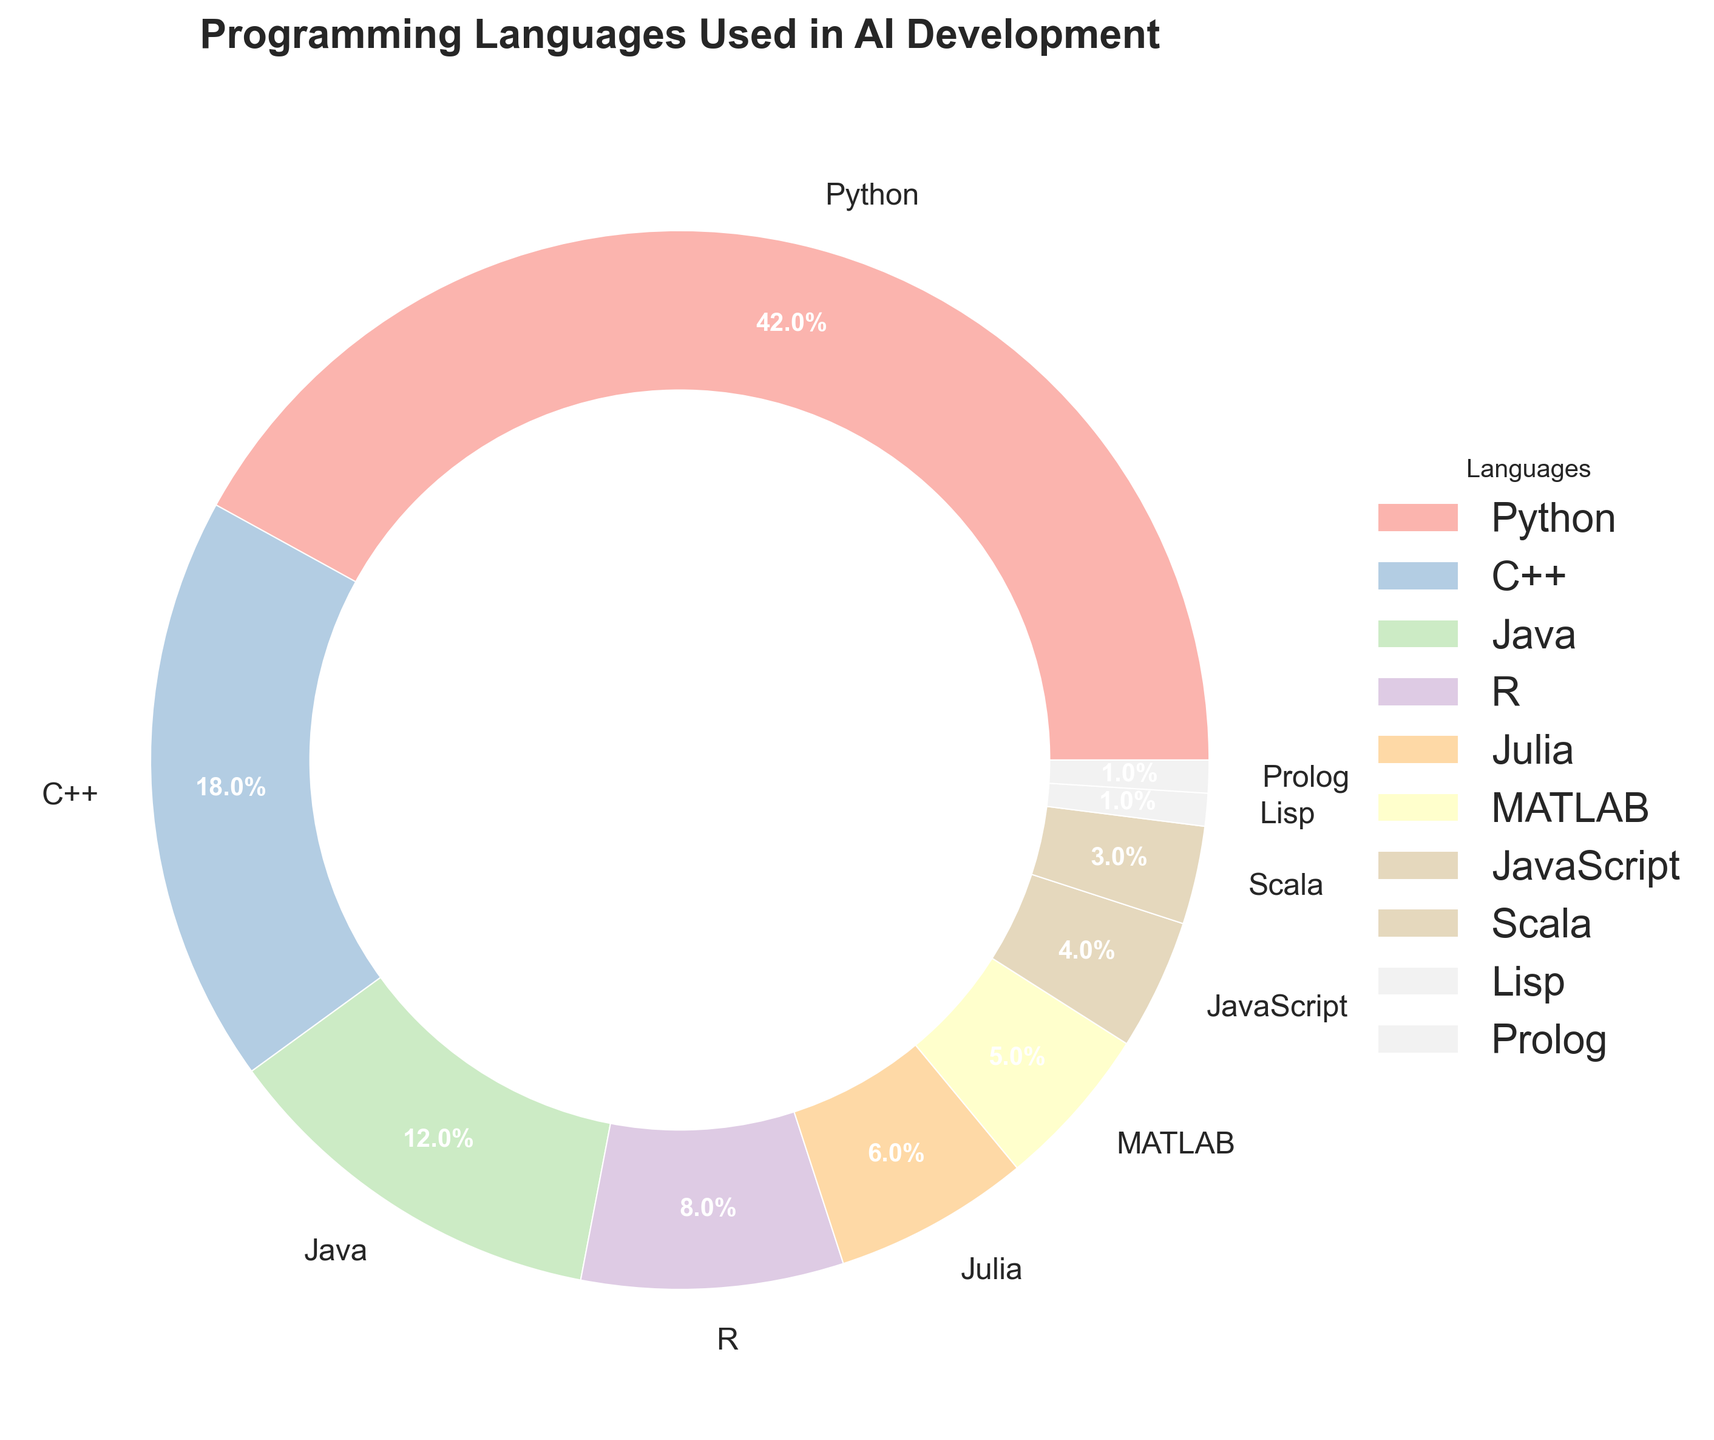What percentage of AI development uses Python compared to C++? Python accounts for 42%, while C++ accounts for 18% according to the pie chart. Comparing the two percentages: 42% (Python) is more than 18% (C++).
Answer: Python: 42%, C++: 18% Which three languages are used the most in AI development? The top three segments in the pie chart are the largest and visually represent the highest percentages. They are Python (42%), C++ (18%), and Java (12%).
Answer: Python, C++, Java What is the total percentage of AI development that uses languages other than Python and C++? To find the total percentage other than Python and C++, we subtract their combined percentage from 100%. Python is 42%, and C++ is 18%, summing up to 60%. So, 100% - 60% = 40%.
Answer: 40% Which language has the smallest share in AI development? The smallest segment in the pie chart represents Lisp and Prolog, each with 1%.
Answer: Lisp, Prolog By how much does Python's usage exceed the combined usage of Julia and MATLAB? Python usage is 42%. Julia and MATLAB combined usage is 6% (Julia) + 5% (MATLAB), totaling 11%. So, Python exceeds by 42% - 11% = 31%.
Answer: 31% What is the combined percentage of Java, R, and JavaScript usage in AI development? Java is 12%, R is 8%, and JavaScript is 4%. Adding these together: 12% + 8% + 4% = 24%.
Answer: 24% How does the percentage of AI development using Julia compare to that using Scala? Julia usage is 6% while Scala usage is 3%. Julia's usage (6%) is double that of Scala's (3%).
Answer: Julia: 6%, Scala: 3% What colors represent the segments for Python and R in the pie chart? The segments would be colored by the custom palette from "seaborn-v0_8-ticks" style. Python and R would have distinct colors in the pastel color scheme, where Python often appears as a light color and R, also a light but distinct hue from Python. **Since the exact hue is not given here, let's infer they are unique pastel shades.**
Answer: Light pastel shades 